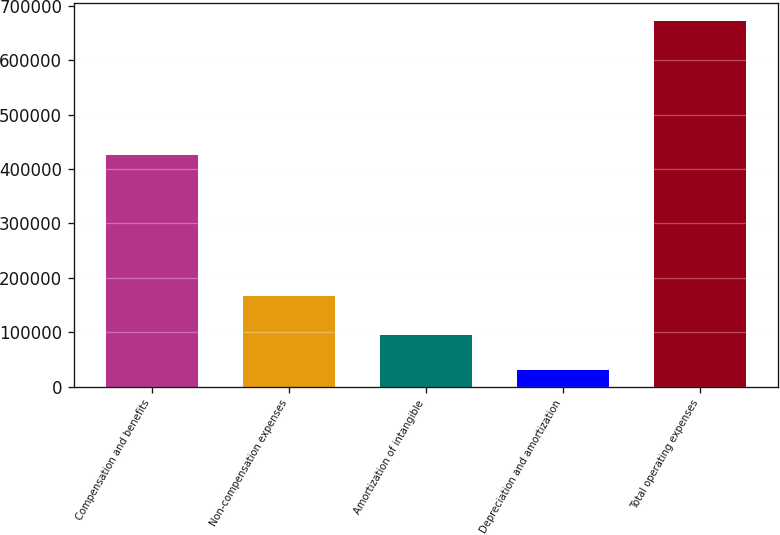Convert chart. <chart><loc_0><loc_0><loc_500><loc_500><bar_chart><fcel>Compensation and benefits<fcel>Non-compensation expenses<fcel>Amortization of intangible<fcel>Depreciation and amortization<fcel>Total operating expenses<nl><fcel>426238<fcel>167078<fcel>94911.6<fcel>30889<fcel>671115<nl></chart> 